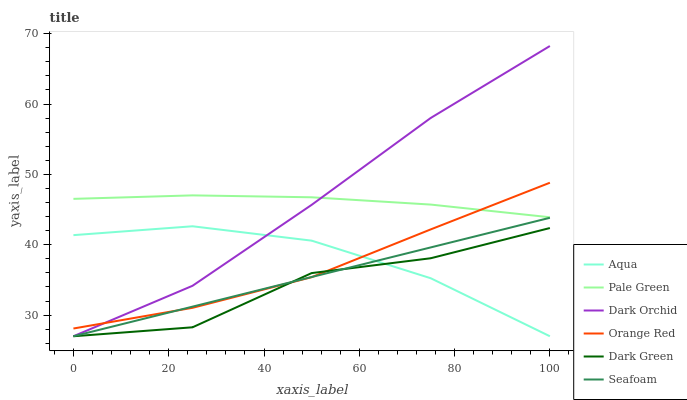Does Dark Green have the minimum area under the curve?
Answer yes or no. Yes. Does Dark Orchid have the maximum area under the curve?
Answer yes or no. Yes. Does Seafoam have the minimum area under the curve?
Answer yes or no. No. Does Seafoam have the maximum area under the curve?
Answer yes or no. No. Is Seafoam the smoothest?
Answer yes or no. Yes. Is Dark Green the roughest?
Answer yes or no. Yes. Is Dark Orchid the smoothest?
Answer yes or no. No. Is Dark Orchid the roughest?
Answer yes or no. No. Does Aqua have the lowest value?
Answer yes or no. Yes. Does Pale Green have the lowest value?
Answer yes or no. No. Does Dark Orchid have the highest value?
Answer yes or no. Yes. Does Seafoam have the highest value?
Answer yes or no. No. Is Aqua less than Pale Green?
Answer yes or no. Yes. Is Pale Green greater than Aqua?
Answer yes or no. Yes. Does Dark Green intersect Orange Red?
Answer yes or no. Yes. Is Dark Green less than Orange Red?
Answer yes or no. No. Is Dark Green greater than Orange Red?
Answer yes or no. No. Does Aqua intersect Pale Green?
Answer yes or no. No. 